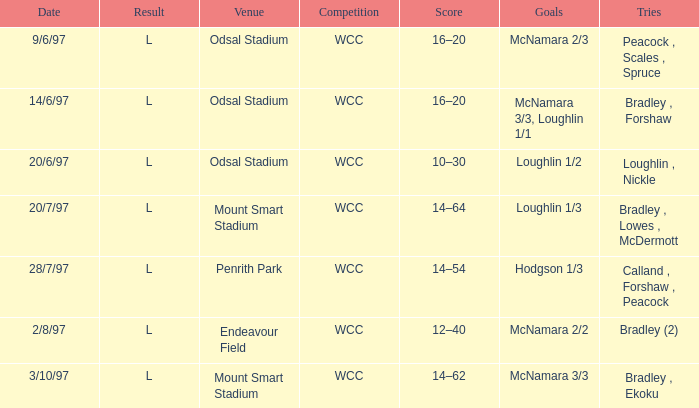What were the tries on 14/6/97? Bradley , Forshaw. 